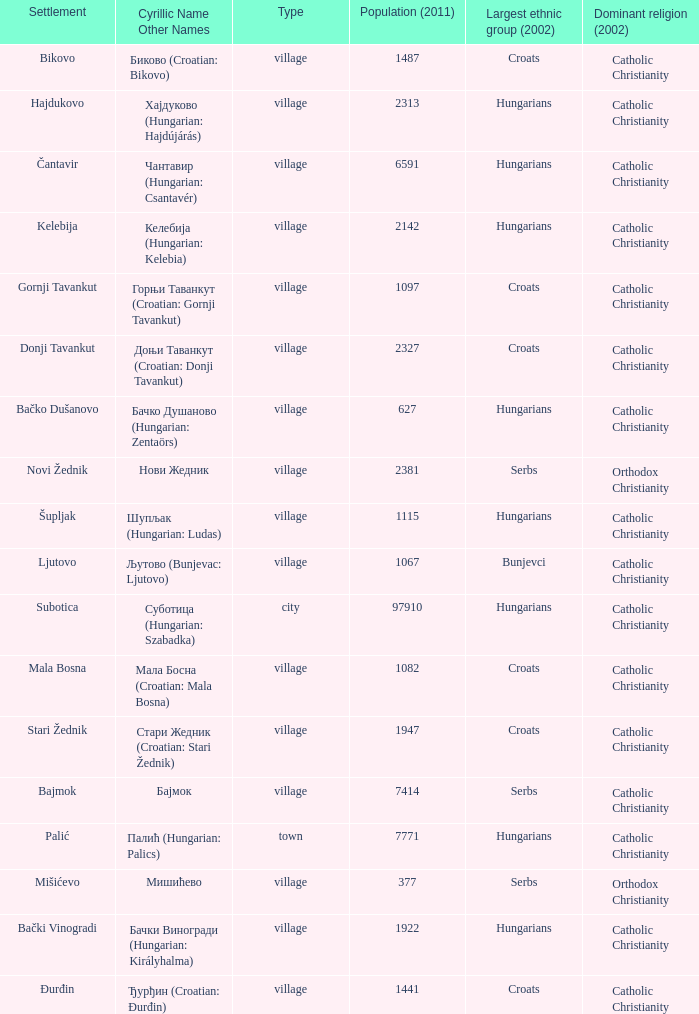Could you parse the entire table as a dict? {'header': ['Settlement', 'Cyrillic Name Other Names', 'Type', 'Population (2011)', 'Largest ethnic group (2002)', 'Dominant religion (2002)'], 'rows': [['Bikovo', 'Биково (Croatian: Bikovo)', 'village', '1487', 'Croats', 'Catholic Christianity'], ['Hajdukovo', 'Хајдуково (Hungarian: Hajdújárás)', 'village', '2313', 'Hungarians', 'Catholic Christianity'], ['Čantavir', 'Чантавир (Hungarian: Csantavér)', 'village', '6591', 'Hungarians', 'Catholic Christianity'], ['Kelebija', 'Келебија (Hungarian: Kelebia)', 'village', '2142', 'Hungarians', 'Catholic Christianity'], ['Gornji Tavankut', 'Горњи Таванкут (Croatian: Gornji Tavankut)', 'village', '1097', 'Croats', 'Catholic Christianity'], ['Donji Tavankut', 'Доњи Таванкут (Croatian: Donji Tavankut)', 'village', '2327', 'Croats', 'Catholic Christianity'], ['Bačko Dušanovo', 'Бачко Душаново (Hungarian: Zentaörs)', 'village', '627', 'Hungarians', 'Catholic Christianity'], ['Novi Žednik', 'Нови Жедник', 'village', '2381', 'Serbs', 'Orthodox Christianity'], ['Šupljak', 'Шупљак (Hungarian: Ludas)', 'village', '1115', 'Hungarians', 'Catholic Christianity'], ['Ljutovo', 'Љутово (Bunjevac: Ljutovo)', 'village', '1067', 'Bunjevci', 'Catholic Christianity'], ['Subotica', 'Суботица (Hungarian: Szabadka)', 'city', '97910', 'Hungarians', 'Catholic Christianity'], ['Mala Bosna', 'Мала Босна (Croatian: Mala Bosna)', 'village', '1082', 'Croats', 'Catholic Christianity'], ['Stari Žednik', 'Стари Жедник (Croatian: Stari Žednik)', 'village', '1947', 'Croats', 'Catholic Christianity'], ['Bajmok', 'Бајмок', 'village', '7414', 'Serbs', 'Catholic Christianity'], ['Palić', 'Палић (Hungarian: Palics)', 'town', '7771', 'Hungarians', 'Catholic Christianity'], ['Mišićevo', 'Мишићево', 'village', '377', 'Serbs', 'Orthodox Christianity'], ['Bački Vinogradi', 'Бачки Виногради (Hungarian: Királyhalma)', 'village', '1922', 'Hungarians', 'Catholic Christianity'], ['Đurđin', 'Ђурђин (Croatian: Đurđin)', 'village', '1441', 'Croats', 'Catholic Christianity']]} How many settlements are named ђурђин (croatian: đurđin)? 1.0. 